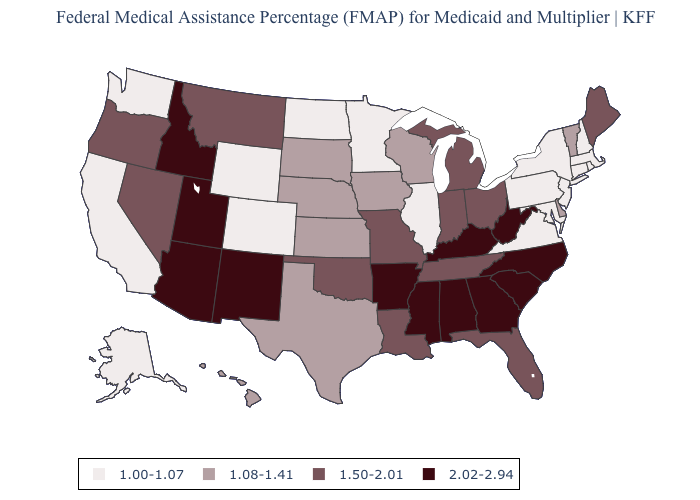Name the states that have a value in the range 2.02-2.94?
Short answer required. Alabama, Arizona, Arkansas, Georgia, Idaho, Kentucky, Mississippi, New Mexico, North Carolina, South Carolina, Utah, West Virginia. Does the map have missing data?
Quick response, please. No. What is the value of West Virginia?
Keep it brief. 2.02-2.94. Does Nevada have the lowest value in the USA?
Quick response, please. No. Which states have the lowest value in the West?
Be succinct. Alaska, California, Colorado, Washington, Wyoming. Among the states that border Kansas , which have the lowest value?
Be succinct. Colorado. What is the highest value in states that border Alabama?
Give a very brief answer. 2.02-2.94. Does Missouri have the highest value in the USA?
Keep it brief. No. Name the states that have a value in the range 1.50-2.01?
Keep it brief. Florida, Indiana, Louisiana, Maine, Michigan, Missouri, Montana, Nevada, Ohio, Oklahoma, Oregon, Tennessee. Name the states that have a value in the range 1.08-1.41?
Concise answer only. Delaware, Hawaii, Iowa, Kansas, Nebraska, South Dakota, Texas, Vermont, Wisconsin. Does Kansas have the lowest value in the USA?
Short answer required. No. Does West Virginia have the highest value in the USA?
Answer briefly. Yes. Name the states that have a value in the range 2.02-2.94?
Give a very brief answer. Alabama, Arizona, Arkansas, Georgia, Idaho, Kentucky, Mississippi, New Mexico, North Carolina, South Carolina, Utah, West Virginia. Is the legend a continuous bar?
Be succinct. No. Name the states that have a value in the range 2.02-2.94?
Give a very brief answer. Alabama, Arizona, Arkansas, Georgia, Idaho, Kentucky, Mississippi, New Mexico, North Carolina, South Carolina, Utah, West Virginia. 